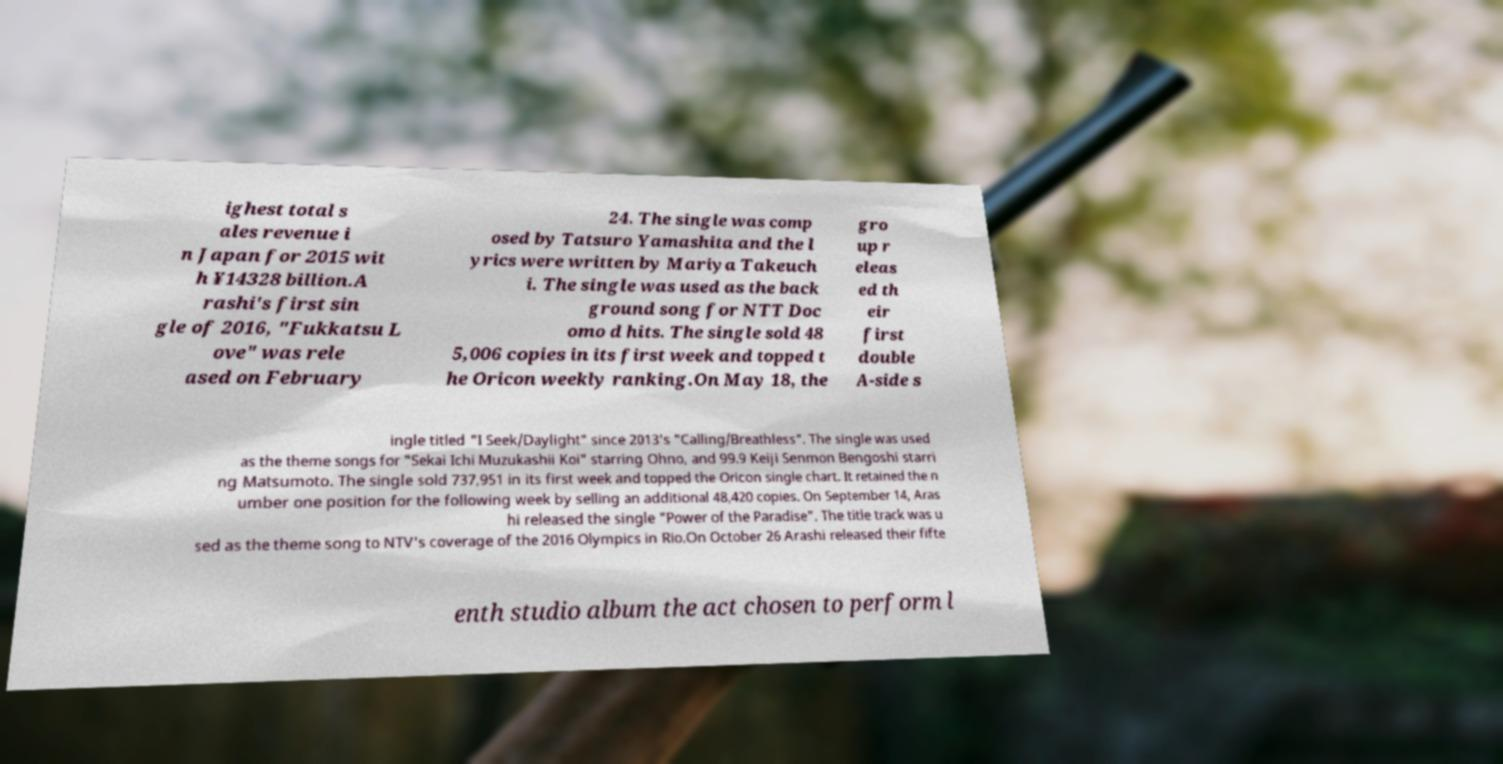Can you accurately transcribe the text from the provided image for me? ighest total s ales revenue i n Japan for 2015 wit h ¥14328 billion.A rashi's first sin gle of 2016, "Fukkatsu L ove" was rele ased on February 24. The single was comp osed by Tatsuro Yamashita and the l yrics were written by Mariya Takeuch i. The single was used as the back ground song for NTT Doc omo d hits. The single sold 48 5,006 copies in its first week and topped t he Oricon weekly ranking.On May 18, the gro up r eleas ed th eir first double A-side s ingle titled "I Seek/Daylight" since 2013's "Calling/Breathless". The single was used as the theme songs for "Sekai Ichi Muzukashii Koi" starring Ohno, and 99.9 Keiji Senmon Bengoshi starri ng Matsumoto. The single sold 737,951 in its first week and topped the Oricon single chart. It retained the n umber one position for the following week by selling an additional 48,420 copies. On September 14, Aras hi released the single "Power of the Paradise". The title track was u sed as the theme song to NTV's coverage of the 2016 Olympics in Rio.On October 26 Arashi released their fifte enth studio album the act chosen to perform l 